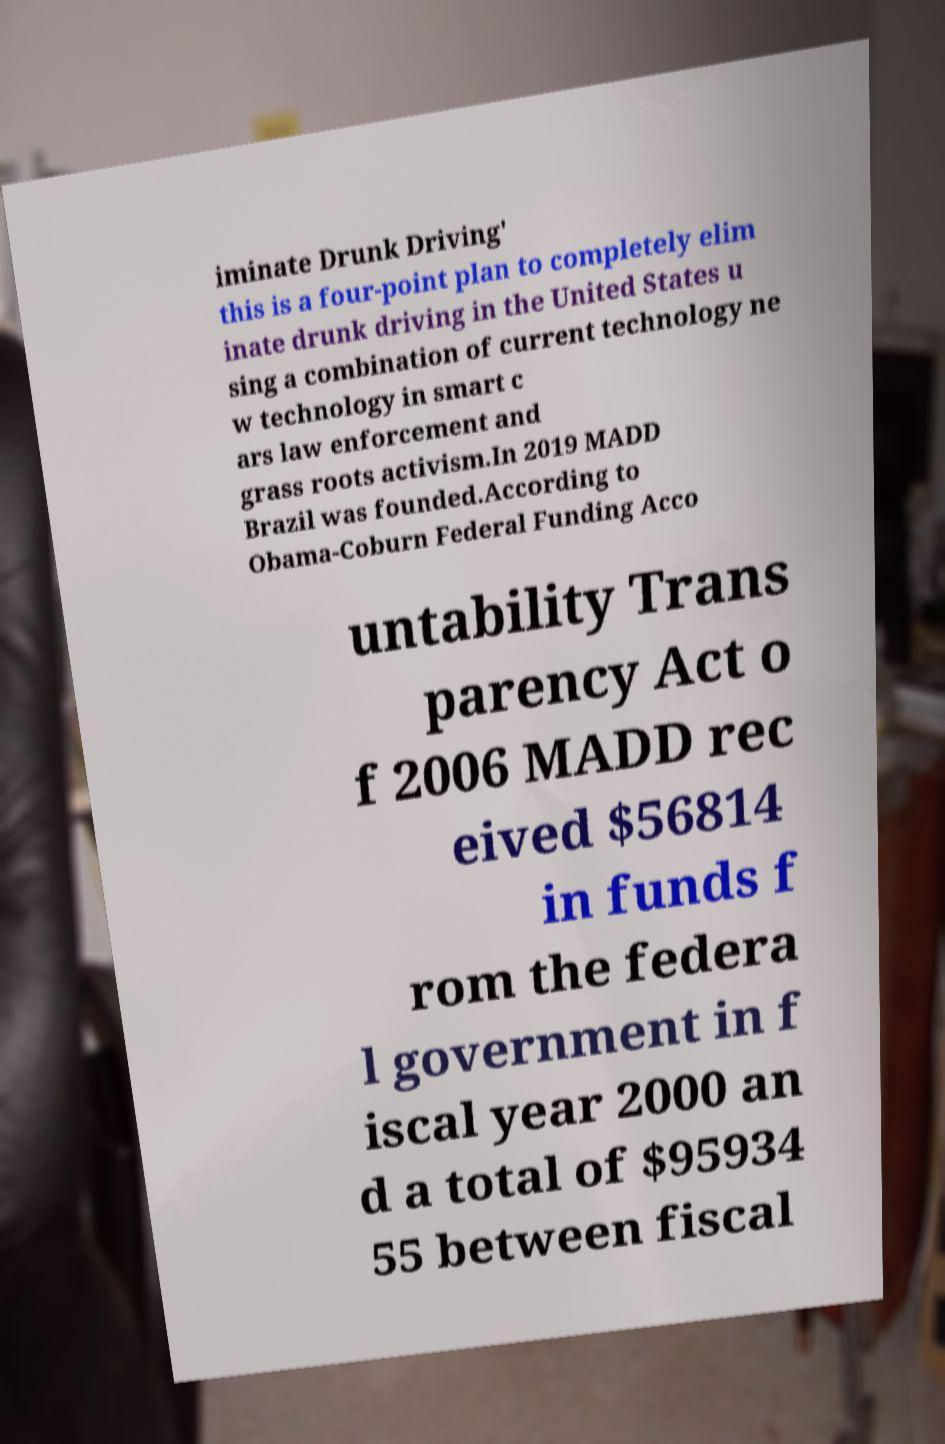I need the written content from this picture converted into text. Can you do that? iminate Drunk Driving' this is a four-point plan to completely elim inate drunk driving in the United States u sing a combination of current technology ne w technology in smart c ars law enforcement and grass roots activism.In 2019 MADD Brazil was founded.According to Obama-Coburn Federal Funding Acco untability Trans parency Act o f 2006 MADD rec eived $56814 in funds f rom the federa l government in f iscal year 2000 an d a total of $95934 55 between fiscal 